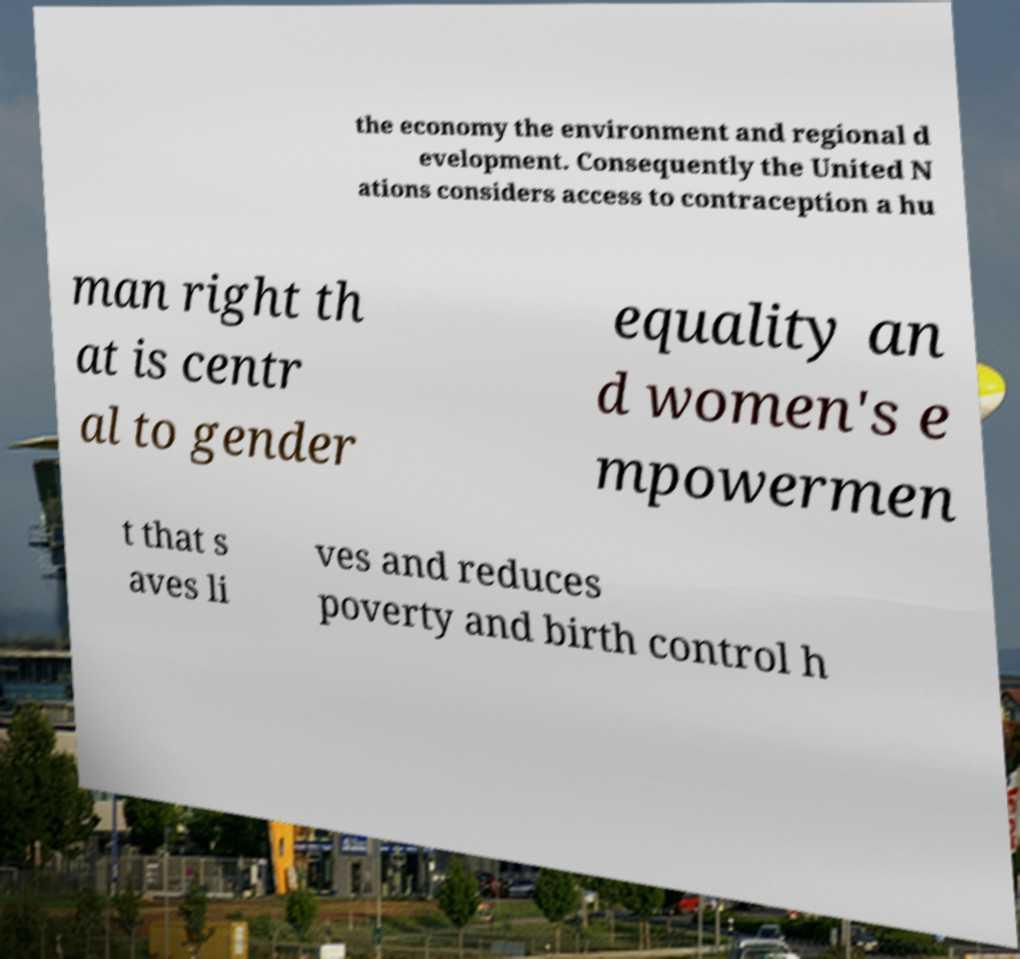There's text embedded in this image that I need extracted. Can you transcribe it verbatim? the economy the environment and regional d evelopment. Consequently the United N ations considers access to contraception a hu man right th at is centr al to gender equality an d women's e mpowermen t that s aves li ves and reduces poverty and birth control h 